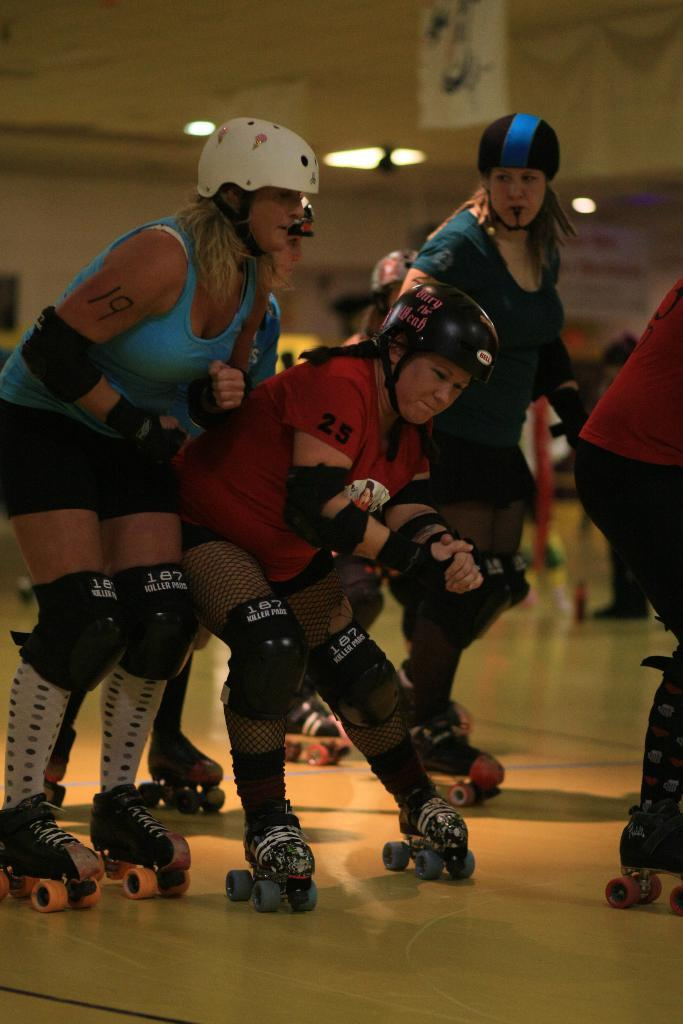What are the people in the image doing? The people in the image are standing on a skateboard. What else can be seen in the image besides the people on the skateboard? There are lights visible in the image. What is present in the background of the image? A board is present in the background of the image. What type of cork can be seen in the image? There is no cork present in the image. How are the people cooking the skateboard in the image? The people are not cooking the skateboard in the image; they are simply standing on it. 